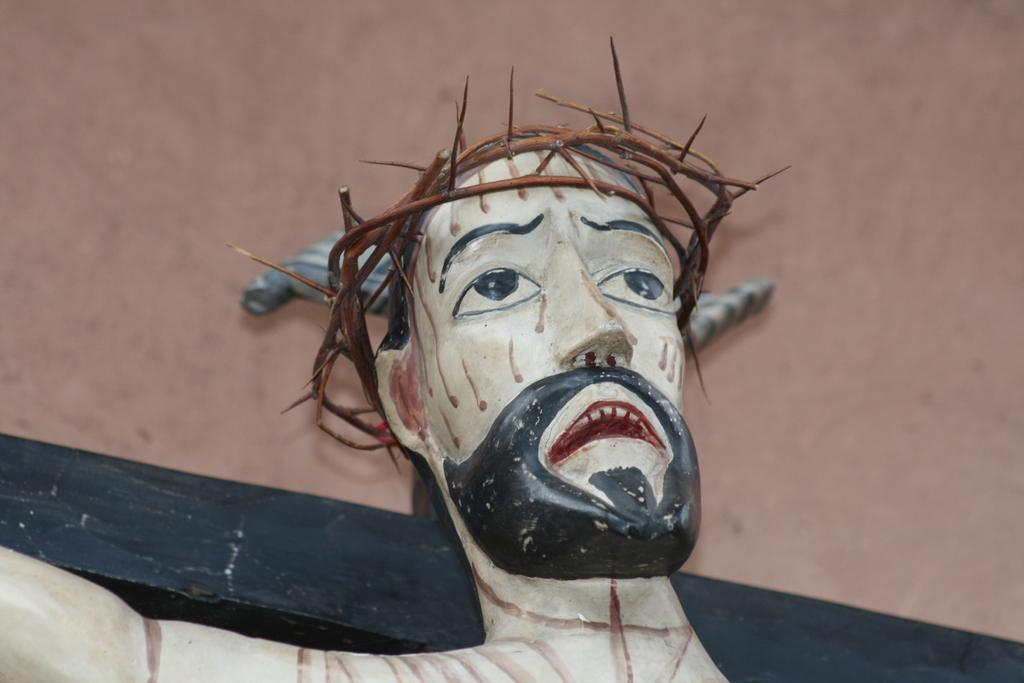What is the main subject of the image? The main subject of the image is a sculpture. Can you describe any other elements in the image? Yes, there is a well at the top of the image. What type of bread is being used to start a fire in the image? There is no bread or fire present in the image; it features a sculpture and a well. How many soldiers are visible in the image? There are no soldiers or army depicted in the image. 